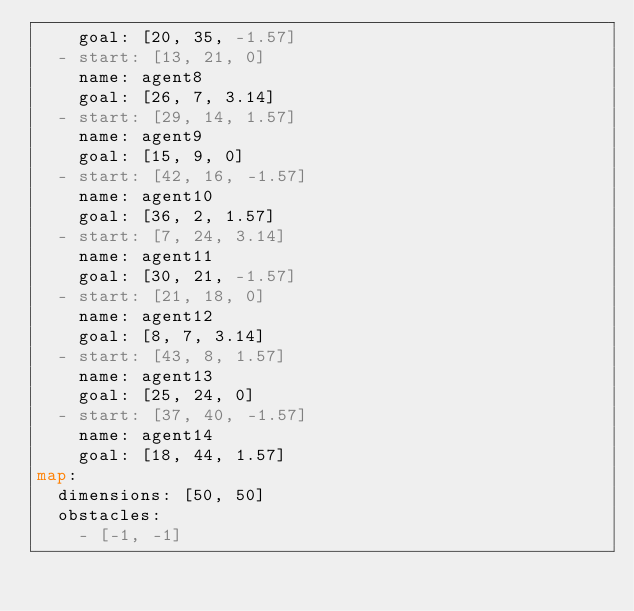Convert code to text. <code><loc_0><loc_0><loc_500><loc_500><_YAML_>    goal: [20, 35, -1.57]
  - start: [13, 21, 0]
    name: agent8
    goal: [26, 7, 3.14]
  - start: [29, 14, 1.57]
    name: agent9
    goal: [15, 9, 0]
  - start: [42, 16, -1.57]
    name: agent10
    goal: [36, 2, 1.57]
  - start: [7, 24, 3.14]
    name: agent11
    goal: [30, 21, -1.57]
  - start: [21, 18, 0]
    name: agent12
    goal: [8, 7, 3.14]
  - start: [43, 8, 1.57]
    name: agent13
    goal: [25, 24, 0]
  - start: [37, 40, -1.57]
    name: agent14
    goal: [18, 44, 1.57]
map:
  dimensions: [50, 50]
  obstacles: 
    - [-1, -1]
</code> 